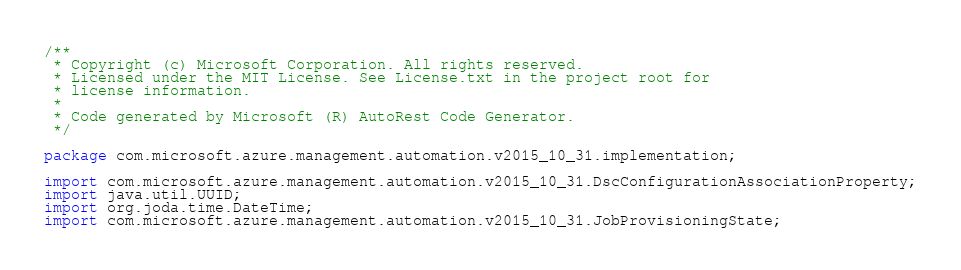<code> <loc_0><loc_0><loc_500><loc_500><_Java_>/**
 * Copyright (c) Microsoft Corporation. All rights reserved.
 * Licensed under the MIT License. See License.txt in the project root for
 * license information.
 *
 * Code generated by Microsoft (R) AutoRest Code Generator.
 */

package com.microsoft.azure.management.automation.v2015_10_31.implementation;

import com.microsoft.azure.management.automation.v2015_10_31.DscConfigurationAssociationProperty;
import java.util.UUID;
import org.joda.time.DateTime;
import com.microsoft.azure.management.automation.v2015_10_31.JobProvisioningState;</code> 